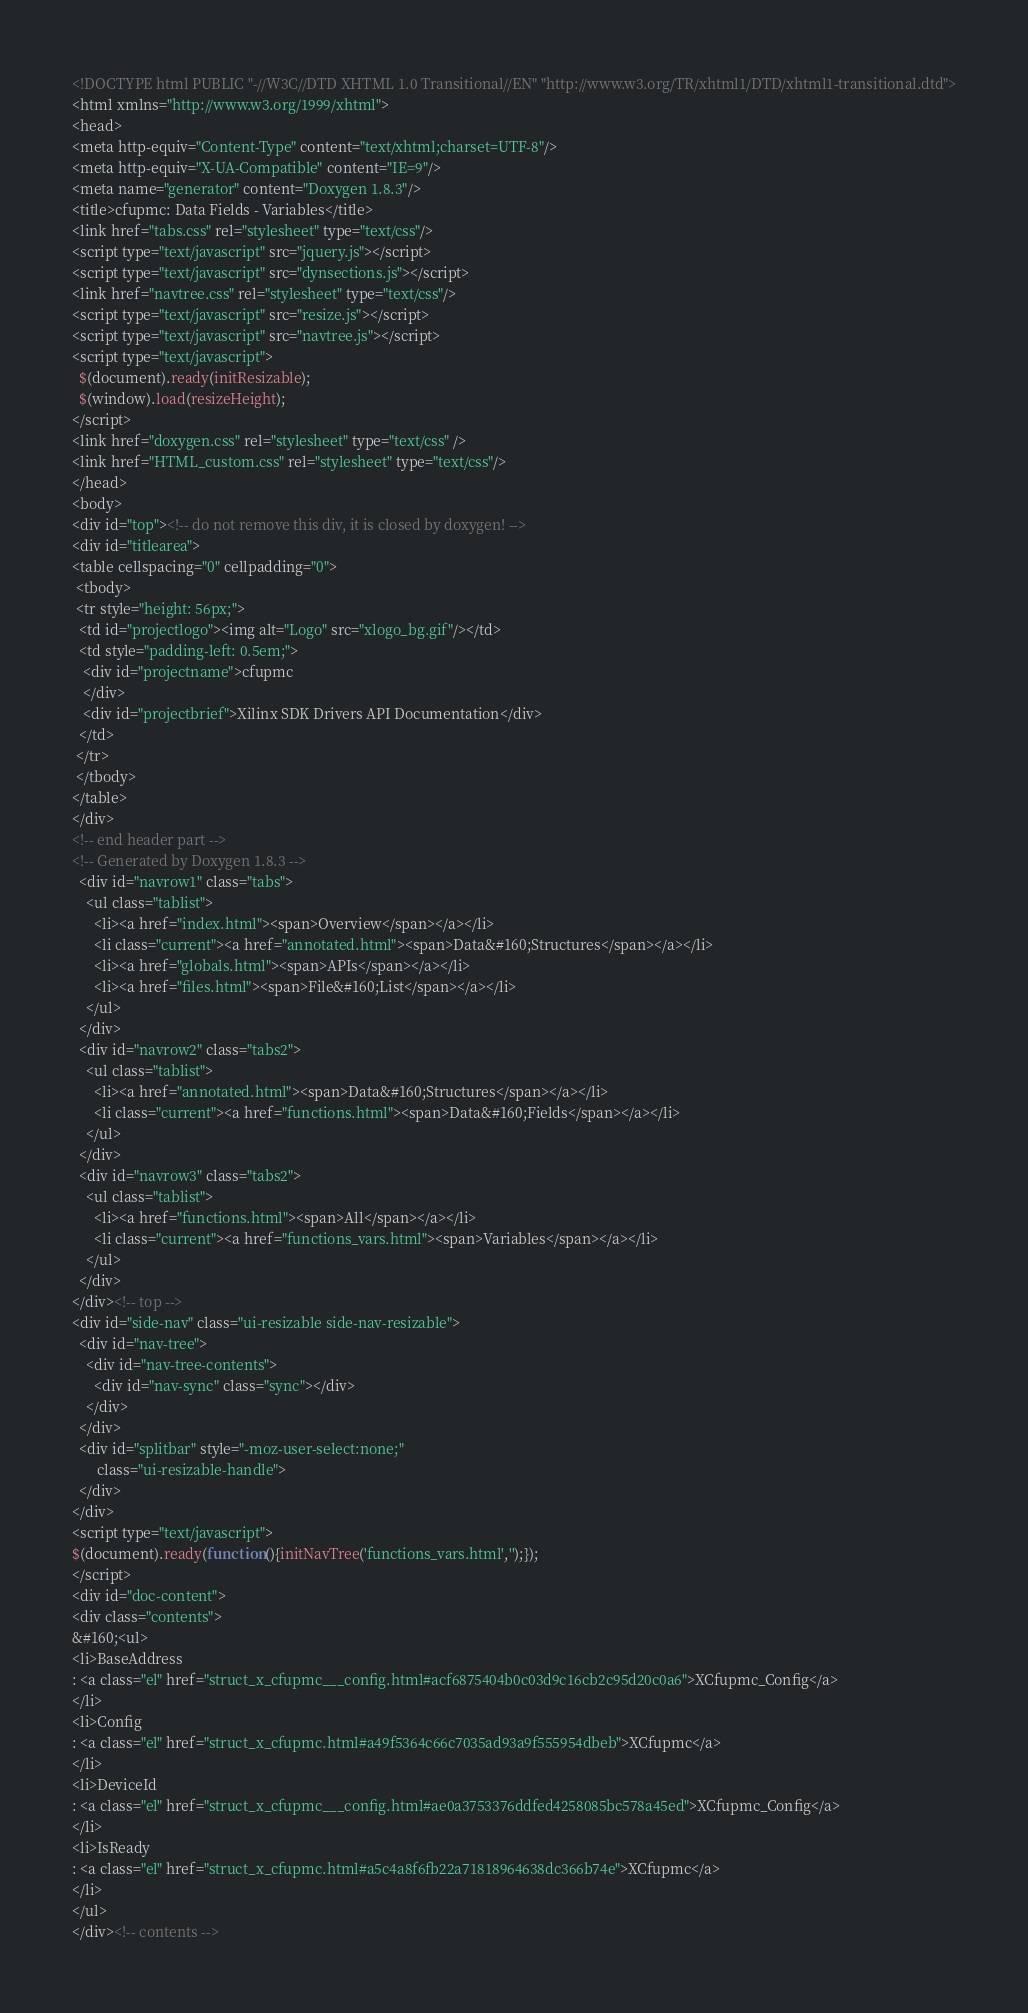Convert code to text. <code><loc_0><loc_0><loc_500><loc_500><_HTML_><!DOCTYPE html PUBLIC "-//W3C//DTD XHTML 1.0 Transitional//EN" "http://www.w3.org/TR/xhtml1/DTD/xhtml1-transitional.dtd">
<html xmlns="http://www.w3.org/1999/xhtml">
<head>
<meta http-equiv="Content-Type" content="text/xhtml;charset=UTF-8"/>
<meta http-equiv="X-UA-Compatible" content="IE=9"/>
<meta name="generator" content="Doxygen 1.8.3"/>
<title>cfupmc: Data Fields - Variables</title>
<link href="tabs.css" rel="stylesheet" type="text/css"/>
<script type="text/javascript" src="jquery.js"></script>
<script type="text/javascript" src="dynsections.js"></script>
<link href="navtree.css" rel="stylesheet" type="text/css"/>
<script type="text/javascript" src="resize.js"></script>
<script type="text/javascript" src="navtree.js"></script>
<script type="text/javascript">
  $(document).ready(initResizable);
  $(window).load(resizeHeight);
</script>
<link href="doxygen.css" rel="stylesheet" type="text/css" />
<link href="HTML_custom.css" rel="stylesheet" type="text/css"/>
</head>
<body>
<div id="top"><!-- do not remove this div, it is closed by doxygen! -->
<div id="titlearea">
<table cellspacing="0" cellpadding="0">
 <tbody>
 <tr style="height: 56px;">
  <td id="projectlogo"><img alt="Logo" src="xlogo_bg.gif"/></td>
  <td style="padding-left: 0.5em;">
   <div id="projectname">cfupmc
   </div>
   <div id="projectbrief">Xilinx SDK Drivers API Documentation</div>
  </td>
 </tr>
 </tbody>
</table>
</div>
<!-- end header part -->
<!-- Generated by Doxygen 1.8.3 -->
  <div id="navrow1" class="tabs">
    <ul class="tablist">
      <li><a href="index.html"><span>Overview</span></a></li>
      <li class="current"><a href="annotated.html"><span>Data&#160;Structures</span></a></li>
      <li><a href="globals.html"><span>APIs</span></a></li>
      <li><a href="files.html"><span>File&#160;List</span></a></li>
    </ul>
  </div>
  <div id="navrow2" class="tabs2">
    <ul class="tablist">
      <li><a href="annotated.html"><span>Data&#160;Structures</span></a></li>
      <li class="current"><a href="functions.html"><span>Data&#160;Fields</span></a></li>
    </ul>
  </div>
  <div id="navrow3" class="tabs2">
    <ul class="tablist">
      <li><a href="functions.html"><span>All</span></a></li>
      <li class="current"><a href="functions_vars.html"><span>Variables</span></a></li>
    </ul>
  </div>
</div><!-- top -->
<div id="side-nav" class="ui-resizable side-nav-resizable">
  <div id="nav-tree">
    <div id="nav-tree-contents">
      <div id="nav-sync" class="sync"></div>
    </div>
  </div>
  <div id="splitbar" style="-moz-user-select:none;" 
       class="ui-resizable-handle">
  </div>
</div>
<script type="text/javascript">
$(document).ready(function(){initNavTree('functions_vars.html','');});
</script>
<div id="doc-content">
<div class="contents">
&#160;<ul>
<li>BaseAddress
: <a class="el" href="struct_x_cfupmc___config.html#acf6875404b0c03d9c16cb2c95d20c0a6">XCfupmc_Config</a>
</li>
<li>Config
: <a class="el" href="struct_x_cfupmc.html#a49f5364c66c7035ad93a9f555954dbeb">XCfupmc</a>
</li>
<li>DeviceId
: <a class="el" href="struct_x_cfupmc___config.html#ae0a3753376ddfed4258085bc578a45ed">XCfupmc_Config</a>
</li>
<li>IsReady
: <a class="el" href="struct_x_cfupmc.html#a5c4a8f6fb22a71818964638dc366b74e">XCfupmc</a>
</li>
</ul>
</div><!-- contents --></code> 